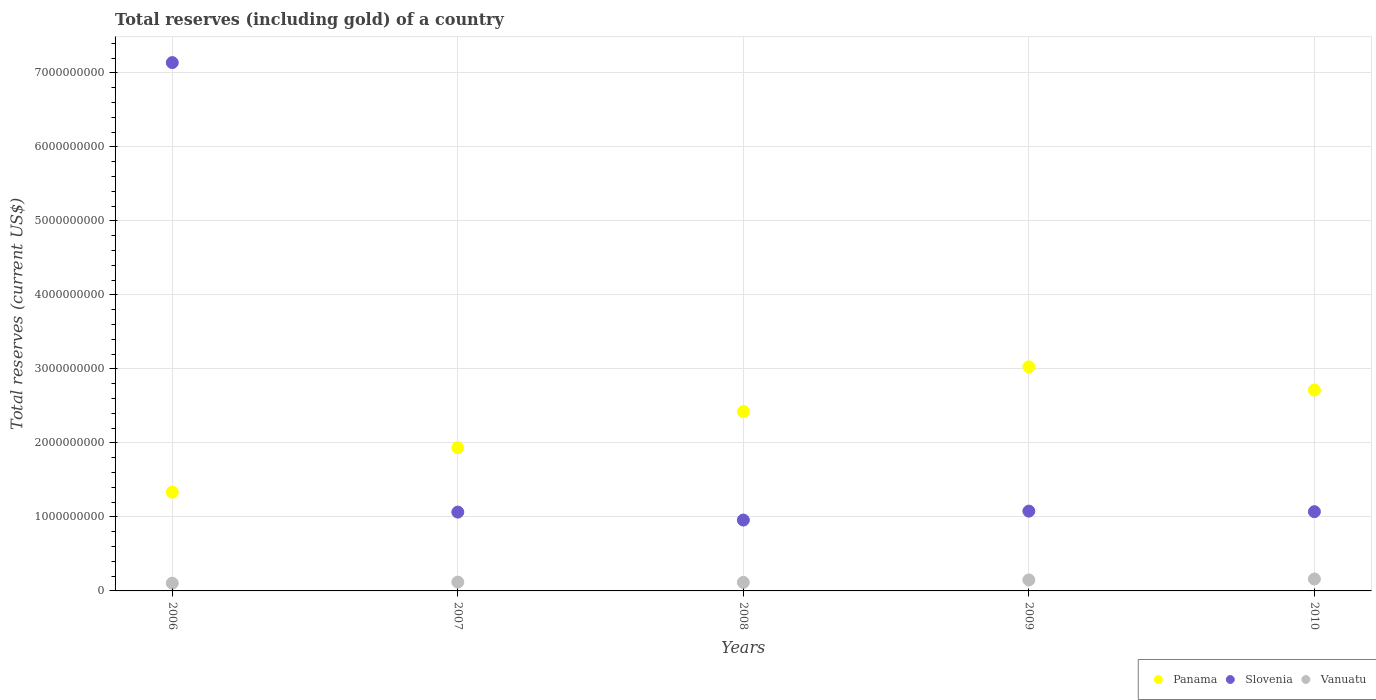How many different coloured dotlines are there?
Give a very brief answer. 3. Is the number of dotlines equal to the number of legend labels?
Provide a short and direct response. Yes. What is the total reserves (including gold) in Panama in 2010?
Your answer should be very brief. 2.71e+09. Across all years, what is the maximum total reserves (including gold) in Slovenia?
Your answer should be compact. 7.14e+09. Across all years, what is the minimum total reserves (including gold) in Slovenia?
Offer a very short reply. 9.58e+08. In which year was the total reserves (including gold) in Slovenia minimum?
Provide a short and direct response. 2008. What is the total total reserves (including gold) in Vanuatu in the graph?
Your response must be concise. 6.50e+08. What is the difference between the total reserves (including gold) in Slovenia in 2008 and that in 2009?
Your response must be concise. -1.21e+08. What is the difference between the total reserves (including gold) in Vanuatu in 2006 and the total reserves (including gold) in Panama in 2009?
Keep it short and to the point. -2.92e+09. What is the average total reserves (including gold) in Slovenia per year?
Give a very brief answer. 2.26e+09. In the year 2008, what is the difference between the total reserves (including gold) in Slovenia and total reserves (including gold) in Panama?
Keep it short and to the point. -1.47e+09. In how many years, is the total reserves (including gold) in Vanuatu greater than 6800000000 US$?
Give a very brief answer. 0. What is the ratio of the total reserves (including gold) in Panama in 2006 to that in 2009?
Provide a short and direct response. 0.44. Is the total reserves (including gold) in Panama in 2006 less than that in 2008?
Your response must be concise. Yes. What is the difference between the highest and the second highest total reserves (including gold) in Slovenia?
Keep it short and to the point. 6.06e+09. What is the difference between the highest and the lowest total reserves (including gold) in Vanuatu?
Your answer should be compact. 5.67e+07. In how many years, is the total reserves (including gold) in Panama greater than the average total reserves (including gold) in Panama taken over all years?
Give a very brief answer. 3. Is the total reserves (including gold) in Vanuatu strictly greater than the total reserves (including gold) in Panama over the years?
Your response must be concise. No. Is the total reserves (including gold) in Panama strictly less than the total reserves (including gold) in Slovenia over the years?
Ensure brevity in your answer.  No. How many dotlines are there?
Offer a very short reply. 3. What is the difference between two consecutive major ticks on the Y-axis?
Give a very brief answer. 1.00e+09. Does the graph contain any zero values?
Ensure brevity in your answer.  No. Does the graph contain grids?
Your answer should be compact. Yes. How many legend labels are there?
Make the answer very short. 3. What is the title of the graph?
Offer a very short reply. Total reserves (including gold) of a country. What is the label or title of the X-axis?
Offer a terse response. Years. What is the label or title of the Y-axis?
Ensure brevity in your answer.  Total reserves (current US$). What is the Total reserves (current US$) in Panama in 2006?
Provide a short and direct response. 1.33e+09. What is the Total reserves (current US$) of Slovenia in 2006?
Make the answer very short. 7.14e+09. What is the Total reserves (current US$) of Vanuatu in 2006?
Make the answer very short. 1.05e+08. What is the Total reserves (current US$) of Panama in 2007?
Provide a short and direct response. 1.94e+09. What is the Total reserves (current US$) of Slovenia in 2007?
Provide a succinct answer. 1.07e+09. What is the Total reserves (current US$) of Vanuatu in 2007?
Your answer should be compact. 1.20e+08. What is the Total reserves (current US$) in Panama in 2008?
Offer a very short reply. 2.42e+09. What is the Total reserves (current US$) of Slovenia in 2008?
Keep it short and to the point. 9.58e+08. What is the Total reserves (current US$) of Vanuatu in 2008?
Keep it short and to the point. 1.15e+08. What is the Total reserves (current US$) of Panama in 2009?
Your response must be concise. 3.03e+09. What is the Total reserves (current US$) of Slovenia in 2009?
Your response must be concise. 1.08e+09. What is the Total reserves (current US$) of Vanuatu in 2009?
Your answer should be very brief. 1.49e+08. What is the Total reserves (current US$) of Panama in 2010?
Offer a very short reply. 2.71e+09. What is the Total reserves (current US$) in Slovenia in 2010?
Provide a short and direct response. 1.07e+09. What is the Total reserves (current US$) in Vanuatu in 2010?
Your answer should be compact. 1.61e+08. Across all years, what is the maximum Total reserves (current US$) in Panama?
Ensure brevity in your answer.  3.03e+09. Across all years, what is the maximum Total reserves (current US$) in Slovenia?
Offer a very short reply. 7.14e+09. Across all years, what is the maximum Total reserves (current US$) of Vanuatu?
Offer a very short reply. 1.61e+08. Across all years, what is the minimum Total reserves (current US$) of Panama?
Ensure brevity in your answer.  1.33e+09. Across all years, what is the minimum Total reserves (current US$) in Slovenia?
Offer a very short reply. 9.58e+08. Across all years, what is the minimum Total reserves (current US$) of Vanuatu?
Make the answer very short. 1.05e+08. What is the total Total reserves (current US$) in Panama in the graph?
Provide a short and direct response. 1.14e+1. What is the total Total reserves (current US$) in Slovenia in the graph?
Offer a terse response. 1.13e+1. What is the total Total reserves (current US$) in Vanuatu in the graph?
Give a very brief answer. 6.50e+08. What is the difference between the Total reserves (current US$) in Panama in 2006 and that in 2007?
Your answer should be very brief. -6.00e+08. What is the difference between the Total reserves (current US$) of Slovenia in 2006 and that in 2007?
Provide a succinct answer. 6.07e+09. What is the difference between the Total reserves (current US$) in Vanuatu in 2006 and that in 2007?
Make the answer very short. -1.50e+07. What is the difference between the Total reserves (current US$) in Panama in 2006 and that in 2008?
Your response must be concise. -1.09e+09. What is the difference between the Total reserves (current US$) of Slovenia in 2006 and that in 2008?
Make the answer very short. 6.18e+09. What is the difference between the Total reserves (current US$) in Vanuatu in 2006 and that in 2008?
Offer a terse response. -1.06e+07. What is the difference between the Total reserves (current US$) in Panama in 2006 and that in 2009?
Give a very brief answer. -1.69e+09. What is the difference between the Total reserves (current US$) of Slovenia in 2006 and that in 2009?
Your response must be concise. 6.06e+09. What is the difference between the Total reserves (current US$) of Vanuatu in 2006 and that in 2009?
Keep it short and to the point. -4.40e+07. What is the difference between the Total reserves (current US$) of Panama in 2006 and that in 2010?
Ensure brevity in your answer.  -1.38e+09. What is the difference between the Total reserves (current US$) of Slovenia in 2006 and that in 2010?
Keep it short and to the point. 6.07e+09. What is the difference between the Total reserves (current US$) in Vanuatu in 2006 and that in 2010?
Your answer should be compact. -5.67e+07. What is the difference between the Total reserves (current US$) in Panama in 2007 and that in 2008?
Provide a succinct answer. -4.89e+08. What is the difference between the Total reserves (current US$) in Slovenia in 2007 and that in 2008?
Provide a short and direct response. 1.08e+08. What is the difference between the Total reserves (current US$) of Vanuatu in 2007 and that in 2008?
Provide a succinct answer. 4.39e+06. What is the difference between the Total reserves (current US$) in Panama in 2007 and that in 2009?
Your answer should be compact. -1.09e+09. What is the difference between the Total reserves (current US$) in Slovenia in 2007 and that in 2009?
Make the answer very short. -1.29e+07. What is the difference between the Total reserves (current US$) of Vanuatu in 2007 and that in 2009?
Keep it short and to the point. -2.90e+07. What is the difference between the Total reserves (current US$) of Panama in 2007 and that in 2010?
Your answer should be compact. -7.79e+08. What is the difference between the Total reserves (current US$) of Slovenia in 2007 and that in 2010?
Offer a terse response. -5.46e+06. What is the difference between the Total reserves (current US$) in Vanuatu in 2007 and that in 2010?
Provide a succinct answer. -4.18e+07. What is the difference between the Total reserves (current US$) in Panama in 2008 and that in 2009?
Keep it short and to the point. -6.04e+08. What is the difference between the Total reserves (current US$) in Slovenia in 2008 and that in 2009?
Your answer should be compact. -1.21e+08. What is the difference between the Total reserves (current US$) in Vanuatu in 2008 and that in 2009?
Your response must be concise. -3.34e+07. What is the difference between the Total reserves (current US$) in Panama in 2008 and that in 2010?
Offer a very short reply. -2.91e+08. What is the difference between the Total reserves (current US$) in Slovenia in 2008 and that in 2010?
Your answer should be compact. -1.13e+08. What is the difference between the Total reserves (current US$) in Vanuatu in 2008 and that in 2010?
Offer a terse response. -4.62e+07. What is the difference between the Total reserves (current US$) of Panama in 2009 and that in 2010?
Give a very brief answer. 3.14e+08. What is the difference between the Total reserves (current US$) of Slovenia in 2009 and that in 2010?
Give a very brief answer. 7.40e+06. What is the difference between the Total reserves (current US$) of Vanuatu in 2009 and that in 2010?
Provide a succinct answer. -1.28e+07. What is the difference between the Total reserves (current US$) of Panama in 2006 and the Total reserves (current US$) of Slovenia in 2007?
Keep it short and to the point. 2.70e+08. What is the difference between the Total reserves (current US$) in Panama in 2006 and the Total reserves (current US$) in Vanuatu in 2007?
Your response must be concise. 1.22e+09. What is the difference between the Total reserves (current US$) of Slovenia in 2006 and the Total reserves (current US$) of Vanuatu in 2007?
Keep it short and to the point. 7.02e+09. What is the difference between the Total reserves (current US$) in Panama in 2006 and the Total reserves (current US$) in Slovenia in 2008?
Make the answer very short. 3.77e+08. What is the difference between the Total reserves (current US$) of Panama in 2006 and the Total reserves (current US$) of Vanuatu in 2008?
Keep it short and to the point. 1.22e+09. What is the difference between the Total reserves (current US$) of Slovenia in 2006 and the Total reserves (current US$) of Vanuatu in 2008?
Provide a succinct answer. 7.02e+09. What is the difference between the Total reserves (current US$) of Panama in 2006 and the Total reserves (current US$) of Slovenia in 2009?
Ensure brevity in your answer.  2.57e+08. What is the difference between the Total reserves (current US$) of Panama in 2006 and the Total reserves (current US$) of Vanuatu in 2009?
Your answer should be very brief. 1.19e+09. What is the difference between the Total reserves (current US$) of Slovenia in 2006 and the Total reserves (current US$) of Vanuatu in 2009?
Offer a terse response. 6.99e+09. What is the difference between the Total reserves (current US$) of Panama in 2006 and the Total reserves (current US$) of Slovenia in 2010?
Your response must be concise. 2.64e+08. What is the difference between the Total reserves (current US$) in Panama in 2006 and the Total reserves (current US$) in Vanuatu in 2010?
Keep it short and to the point. 1.17e+09. What is the difference between the Total reserves (current US$) of Slovenia in 2006 and the Total reserves (current US$) of Vanuatu in 2010?
Keep it short and to the point. 6.98e+09. What is the difference between the Total reserves (current US$) in Panama in 2007 and the Total reserves (current US$) in Slovenia in 2008?
Offer a very short reply. 9.77e+08. What is the difference between the Total reserves (current US$) of Panama in 2007 and the Total reserves (current US$) of Vanuatu in 2008?
Make the answer very short. 1.82e+09. What is the difference between the Total reserves (current US$) in Slovenia in 2007 and the Total reserves (current US$) in Vanuatu in 2008?
Your answer should be compact. 9.50e+08. What is the difference between the Total reserves (current US$) of Panama in 2007 and the Total reserves (current US$) of Slovenia in 2009?
Keep it short and to the point. 8.57e+08. What is the difference between the Total reserves (current US$) of Panama in 2007 and the Total reserves (current US$) of Vanuatu in 2009?
Your response must be concise. 1.79e+09. What is the difference between the Total reserves (current US$) of Slovenia in 2007 and the Total reserves (current US$) of Vanuatu in 2009?
Give a very brief answer. 9.17e+08. What is the difference between the Total reserves (current US$) of Panama in 2007 and the Total reserves (current US$) of Slovenia in 2010?
Give a very brief answer. 8.64e+08. What is the difference between the Total reserves (current US$) of Panama in 2007 and the Total reserves (current US$) of Vanuatu in 2010?
Keep it short and to the point. 1.77e+09. What is the difference between the Total reserves (current US$) in Slovenia in 2007 and the Total reserves (current US$) in Vanuatu in 2010?
Make the answer very short. 9.04e+08. What is the difference between the Total reserves (current US$) of Panama in 2008 and the Total reserves (current US$) of Slovenia in 2009?
Keep it short and to the point. 1.35e+09. What is the difference between the Total reserves (current US$) in Panama in 2008 and the Total reserves (current US$) in Vanuatu in 2009?
Keep it short and to the point. 2.28e+09. What is the difference between the Total reserves (current US$) in Slovenia in 2008 and the Total reserves (current US$) in Vanuatu in 2009?
Your answer should be compact. 8.09e+08. What is the difference between the Total reserves (current US$) of Panama in 2008 and the Total reserves (current US$) of Slovenia in 2010?
Your answer should be compact. 1.35e+09. What is the difference between the Total reserves (current US$) of Panama in 2008 and the Total reserves (current US$) of Vanuatu in 2010?
Provide a short and direct response. 2.26e+09. What is the difference between the Total reserves (current US$) in Slovenia in 2008 and the Total reserves (current US$) in Vanuatu in 2010?
Keep it short and to the point. 7.96e+08. What is the difference between the Total reserves (current US$) in Panama in 2009 and the Total reserves (current US$) in Slovenia in 2010?
Keep it short and to the point. 1.96e+09. What is the difference between the Total reserves (current US$) of Panama in 2009 and the Total reserves (current US$) of Vanuatu in 2010?
Offer a very short reply. 2.87e+09. What is the difference between the Total reserves (current US$) of Slovenia in 2009 and the Total reserves (current US$) of Vanuatu in 2010?
Offer a very short reply. 9.17e+08. What is the average Total reserves (current US$) of Panama per year?
Provide a short and direct response. 2.29e+09. What is the average Total reserves (current US$) in Slovenia per year?
Keep it short and to the point. 2.26e+09. What is the average Total reserves (current US$) in Vanuatu per year?
Your answer should be very brief. 1.30e+08. In the year 2006, what is the difference between the Total reserves (current US$) in Panama and Total reserves (current US$) in Slovenia?
Provide a short and direct response. -5.80e+09. In the year 2006, what is the difference between the Total reserves (current US$) in Panama and Total reserves (current US$) in Vanuatu?
Offer a terse response. 1.23e+09. In the year 2006, what is the difference between the Total reserves (current US$) in Slovenia and Total reserves (current US$) in Vanuatu?
Provide a succinct answer. 7.03e+09. In the year 2007, what is the difference between the Total reserves (current US$) in Panama and Total reserves (current US$) in Slovenia?
Make the answer very short. 8.70e+08. In the year 2007, what is the difference between the Total reserves (current US$) of Panama and Total reserves (current US$) of Vanuatu?
Your response must be concise. 1.82e+09. In the year 2007, what is the difference between the Total reserves (current US$) in Slovenia and Total reserves (current US$) in Vanuatu?
Keep it short and to the point. 9.46e+08. In the year 2008, what is the difference between the Total reserves (current US$) in Panama and Total reserves (current US$) in Slovenia?
Your answer should be compact. 1.47e+09. In the year 2008, what is the difference between the Total reserves (current US$) in Panama and Total reserves (current US$) in Vanuatu?
Make the answer very short. 2.31e+09. In the year 2008, what is the difference between the Total reserves (current US$) in Slovenia and Total reserves (current US$) in Vanuatu?
Your answer should be compact. 8.42e+08. In the year 2009, what is the difference between the Total reserves (current US$) in Panama and Total reserves (current US$) in Slovenia?
Provide a short and direct response. 1.95e+09. In the year 2009, what is the difference between the Total reserves (current US$) of Panama and Total reserves (current US$) of Vanuatu?
Offer a terse response. 2.88e+09. In the year 2009, what is the difference between the Total reserves (current US$) in Slovenia and Total reserves (current US$) in Vanuatu?
Offer a very short reply. 9.30e+08. In the year 2010, what is the difference between the Total reserves (current US$) in Panama and Total reserves (current US$) in Slovenia?
Offer a terse response. 1.64e+09. In the year 2010, what is the difference between the Total reserves (current US$) of Panama and Total reserves (current US$) of Vanuatu?
Your response must be concise. 2.55e+09. In the year 2010, what is the difference between the Total reserves (current US$) of Slovenia and Total reserves (current US$) of Vanuatu?
Ensure brevity in your answer.  9.09e+08. What is the ratio of the Total reserves (current US$) of Panama in 2006 to that in 2007?
Make the answer very short. 0.69. What is the ratio of the Total reserves (current US$) of Slovenia in 2006 to that in 2007?
Provide a short and direct response. 6.7. What is the ratio of the Total reserves (current US$) in Vanuatu in 2006 to that in 2007?
Make the answer very short. 0.87. What is the ratio of the Total reserves (current US$) of Panama in 2006 to that in 2008?
Your response must be concise. 0.55. What is the ratio of the Total reserves (current US$) of Slovenia in 2006 to that in 2008?
Offer a very short reply. 7.46. What is the ratio of the Total reserves (current US$) in Vanuatu in 2006 to that in 2008?
Keep it short and to the point. 0.91. What is the ratio of the Total reserves (current US$) of Panama in 2006 to that in 2009?
Provide a succinct answer. 0.44. What is the ratio of the Total reserves (current US$) of Slovenia in 2006 to that in 2009?
Your answer should be compact. 6.62. What is the ratio of the Total reserves (current US$) in Vanuatu in 2006 to that in 2009?
Offer a very short reply. 0.7. What is the ratio of the Total reserves (current US$) of Panama in 2006 to that in 2010?
Offer a terse response. 0.49. What is the ratio of the Total reserves (current US$) of Slovenia in 2006 to that in 2010?
Provide a short and direct response. 6.67. What is the ratio of the Total reserves (current US$) of Vanuatu in 2006 to that in 2010?
Offer a very short reply. 0.65. What is the ratio of the Total reserves (current US$) of Panama in 2007 to that in 2008?
Provide a succinct answer. 0.8. What is the ratio of the Total reserves (current US$) in Slovenia in 2007 to that in 2008?
Offer a very short reply. 1.11. What is the ratio of the Total reserves (current US$) in Vanuatu in 2007 to that in 2008?
Provide a succinct answer. 1.04. What is the ratio of the Total reserves (current US$) of Panama in 2007 to that in 2009?
Your answer should be compact. 0.64. What is the ratio of the Total reserves (current US$) in Vanuatu in 2007 to that in 2009?
Offer a terse response. 0.8. What is the ratio of the Total reserves (current US$) in Panama in 2007 to that in 2010?
Make the answer very short. 0.71. What is the ratio of the Total reserves (current US$) in Vanuatu in 2007 to that in 2010?
Provide a succinct answer. 0.74. What is the ratio of the Total reserves (current US$) in Panama in 2008 to that in 2009?
Ensure brevity in your answer.  0.8. What is the ratio of the Total reserves (current US$) of Slovenia in 2008 to that in 2009?
Provide a short and direct response. 0.89. What is the ratio of the Total reserves (current US$) in Vanuatu in 2008 to that in 2009?
Your answer should be very brief. 0.78. What is the ratio of the Total reserves (current US$) in Panama in 2008 to that in 2010?
Give a very brief answer. 0.89. What is the ratio of the Total reserves (current US$) of Slovenia in 2008 to that in 2010?
Offer a very short reply. 0.89. What is the ratio of the Total reserves (current US$) of Vanuatu in 2008 to that in 2010?
Your answer should be compact. 0.71. What is the ratio of the Total reserves (current US$) of Panama in 2009 to that in 2010?
Your answer should be compact. 1.12. What is the ratio of the Total reserves (current US$) in Slovenia in 2009 to that in 2010?
Your answer should be compact. 1.01. What is the ratio of the Total reserves (current US$) in Vanuatu in 2009 to that in 2010?
Your answer should be compact. 0.92. What is the difference between the highest and the second highest Total reserves (current US$) of Panama?
Your answer should be compact. 3.14e+08. What is the difference between the highest and the second highest Total reserves (current US$) in Slovenia?
Provide a short and direct response. 6.06e+09. What is the difference between the highest and the second highest Total reserves (current US$) of Vanuatu?
Provide a short and direct response. 1.28e+07. What is the difference between the highest and the lowest Total reserves (current US$) in Panama?
Your answer should be compact. 1.69e+09. What is the difference between the highest and the lowest Total reserves (current US$) of Slovenia?
Keep it short and to the point. 6.18e+09. What is the difference between the highest and the lowest Total reserves (current US$) of Vanuatu?
Your answer should be very brief. 5.67e+07. 